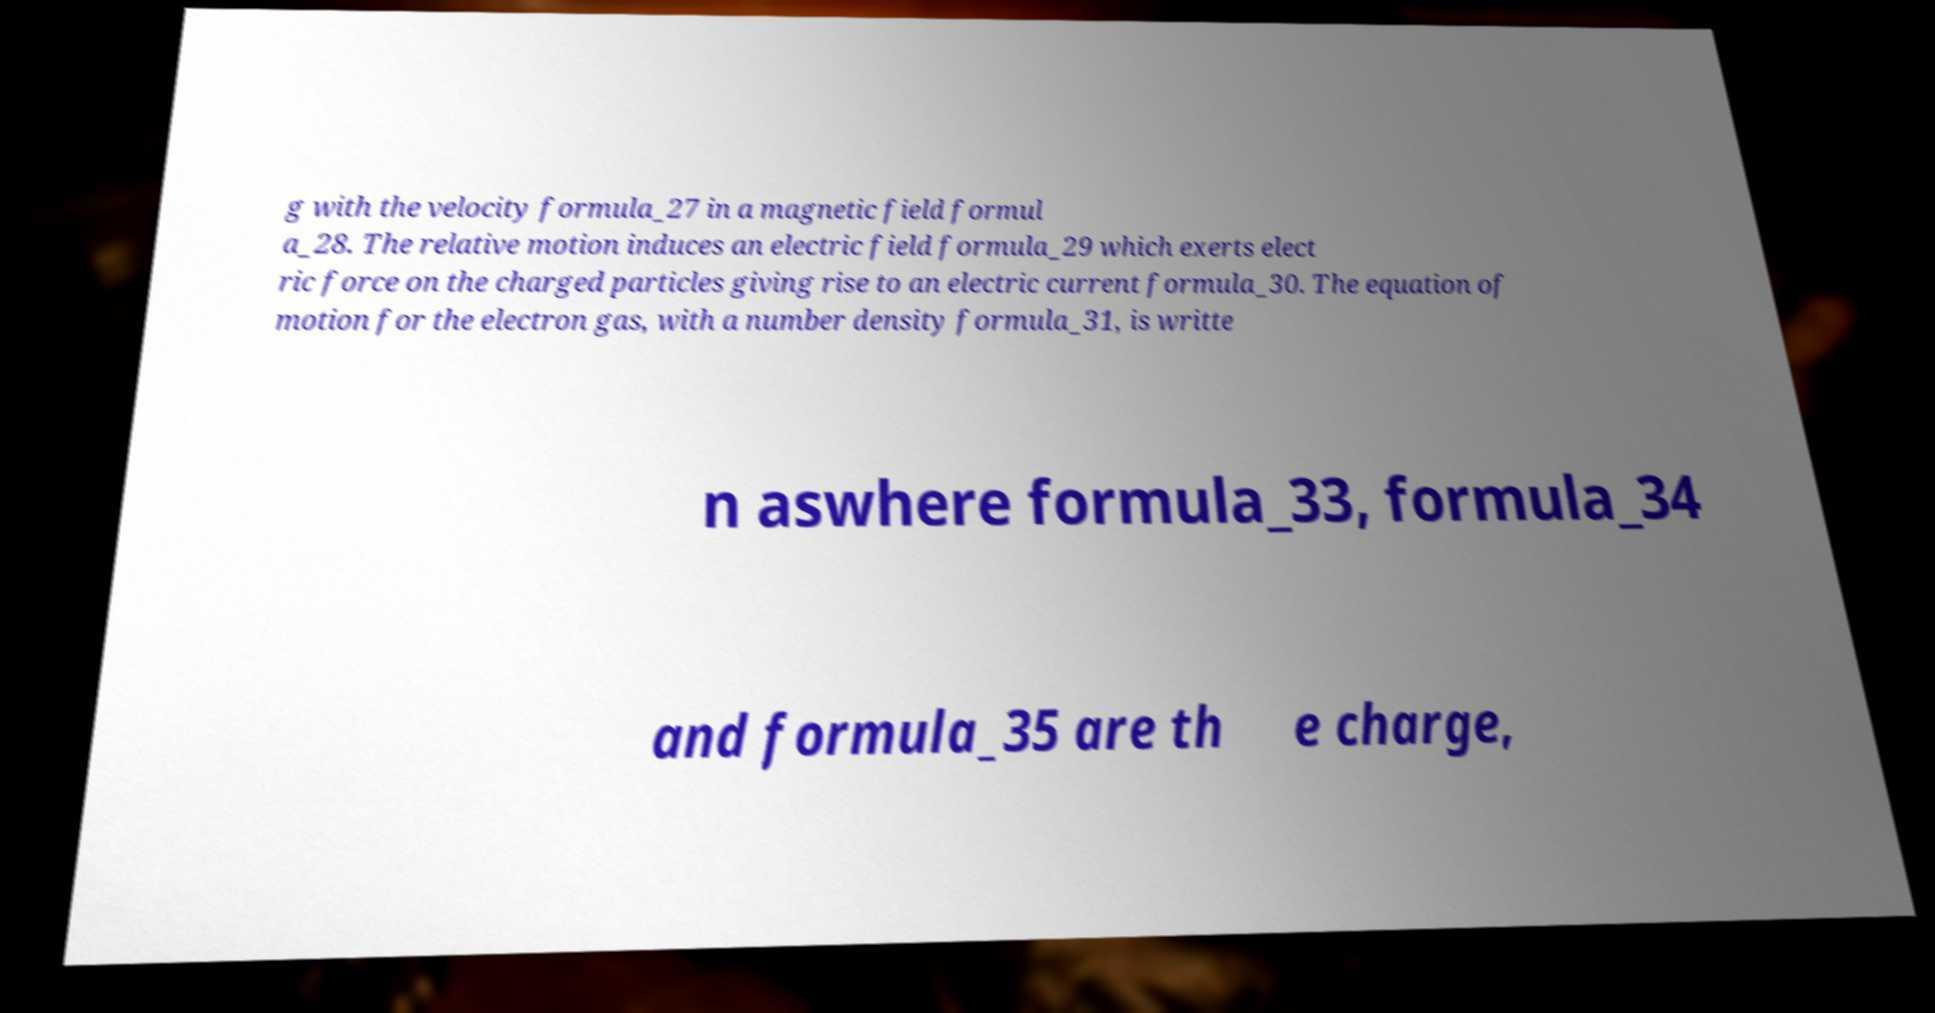Please identify and transcribe the text found in this image. g with the velocity formula_27 in a magnetic field formul a_28. The relative motion induces an electric field formula_29 which exerts elect ric force on the charged particles giving rise to an electric current formula_30. The equation of motion for the electron gas, with a number density formula_31, is writte n aswhere formula_33, formula_34 and formula_35 are th e charge, 